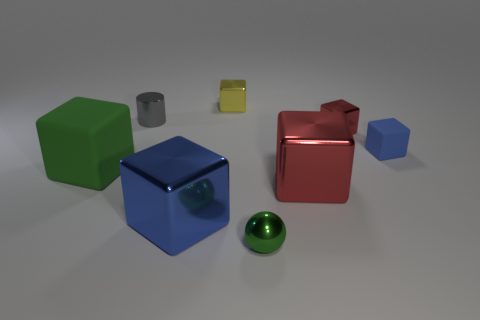Is there any other thing that has the same shape as the gray metal thing?
Keep it short and to the point. No. There is a small object that is the same color as the large matte cube; what is its shape?
Offer a terse response. Sphere. What number of big blue things have the same material as the small gray object?
Your response must be concise. 1. The tiny rubber cube is what color?
Your response must be concise. Blue. Does the big shiny thing right of the yellow thing have the same shape as the small blue object in front of the yellow metal cube?
Offer a terse response. Yes. What is the color of the rubber block in front of the blue matte cube?
Your answer should be very brief. Green. Are there fewer small yellow metal things in front of the tiny red metallic cube than small metal things behind the metallic cylinder?
Offer a terse response. Yes. How many other things are made of the same material as the big blue object?
Ensure brevity in your answer.  5. Are the small red thing and the large green thing made of the same material?
Offer a terse response. No. What number of other objects are the same size as the blue metal block?
Provide a succinct answer. 2. 